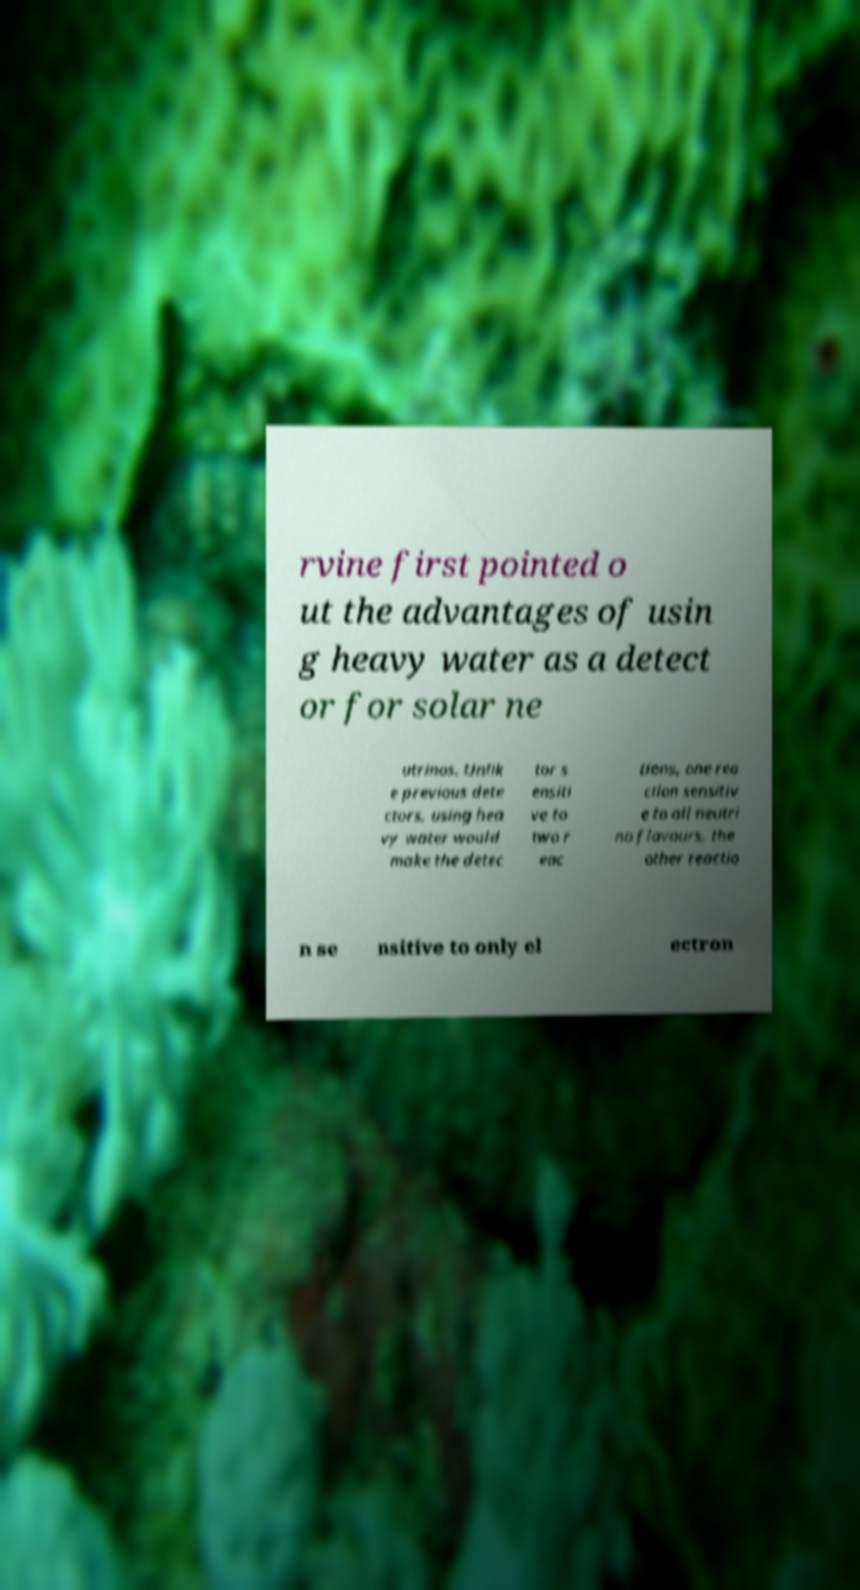Please read and relay the text visible in this image. What does it say? rvine first pointed o ut the advantages of usin g heavy water as a detect or for solar ne utrinos. Unlik e previous dete ctors, using hea vy water would make the detec tor s ensiti ve to two r eac tions, one rea ction sensitiv e to all neutri no flavours, the other reactio n se nsitive to only el ectron 